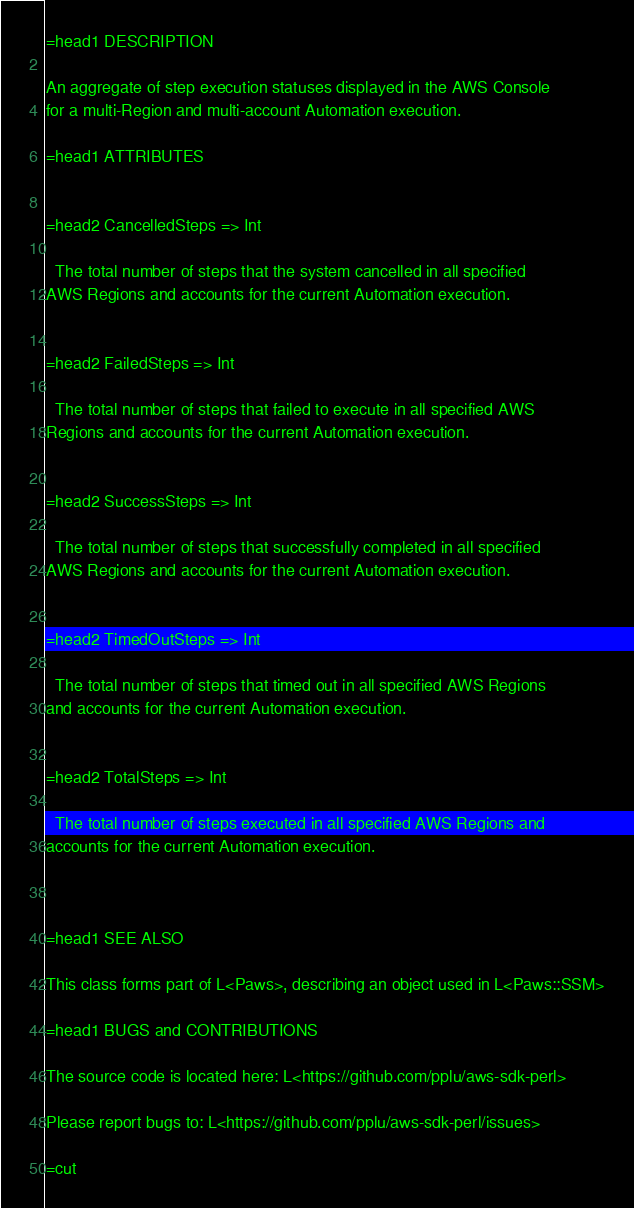Convert code to text. <code><loc_0><loc_0><loc_500><loc_500><_Perl_>
=head1 DESCRIPTION

An aggregate of step execution statuses displayed in the AWS Console
for a multi-Region and multi-account Automation execution.

=head1 ATTRIBUTES


=head2 CancelledSteps => Int

  The total number of steps that the system cancelled in all specified
AWS Regions and accounts for the current Automation execution.


=head2 FailedSteps => Int

  The total number of steps that failed to execute in all specified AWS
Regions and accounts for the current Automation execution.


=head2 SuccessSteps => Int

  The total number of steps that successfully completed in all specified
AWS Regions and accounts for the current Automation execution.


=head2 TimedOutSteps => Int

  The total number of steps that timed out in all specified AWS Regions
and accounts for the current Automation execution.


=head2 TotalSteps => Int

  The total number of steps executed in all specified AWS Regions and
accounts for the current Automation execution.



=head1 SEE ALSO

This class forms part of L<Paws>, describing an object used in L<Paws::SSM>

=head1 BUGS and CONTRIBUTIONS

The source code is located here: L<https://github.com/pplu/aws-sdk-perl>

Please report bugs to: L<https://github.com/pplu/aws-sdk-perl/issues>

=cut

</code> 